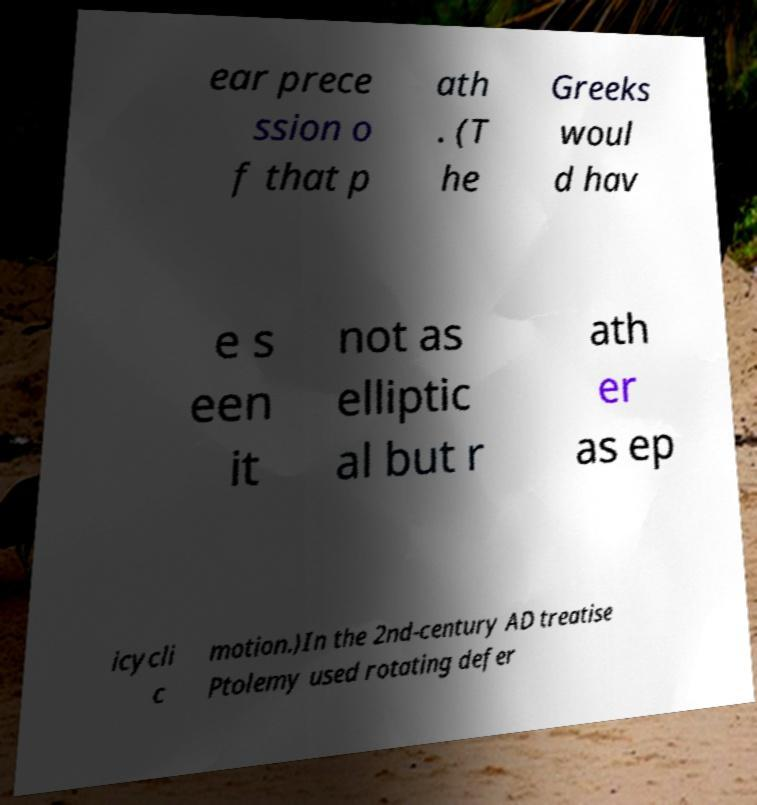Could you extract and type out the text from this image? ear prece ssion o f that p ath . (T he Greeks woul d hav e s een it not as elliptic al but r ath er as ep icycli c motion.)In the 2nd-century AD treatise Ptolemy used rotating defer 